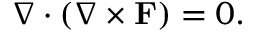<formula> <loc_0><loc_0><loc_500><loc_500>\nabla \cdot ( \nabla \times F ) = 0 .</formula> 